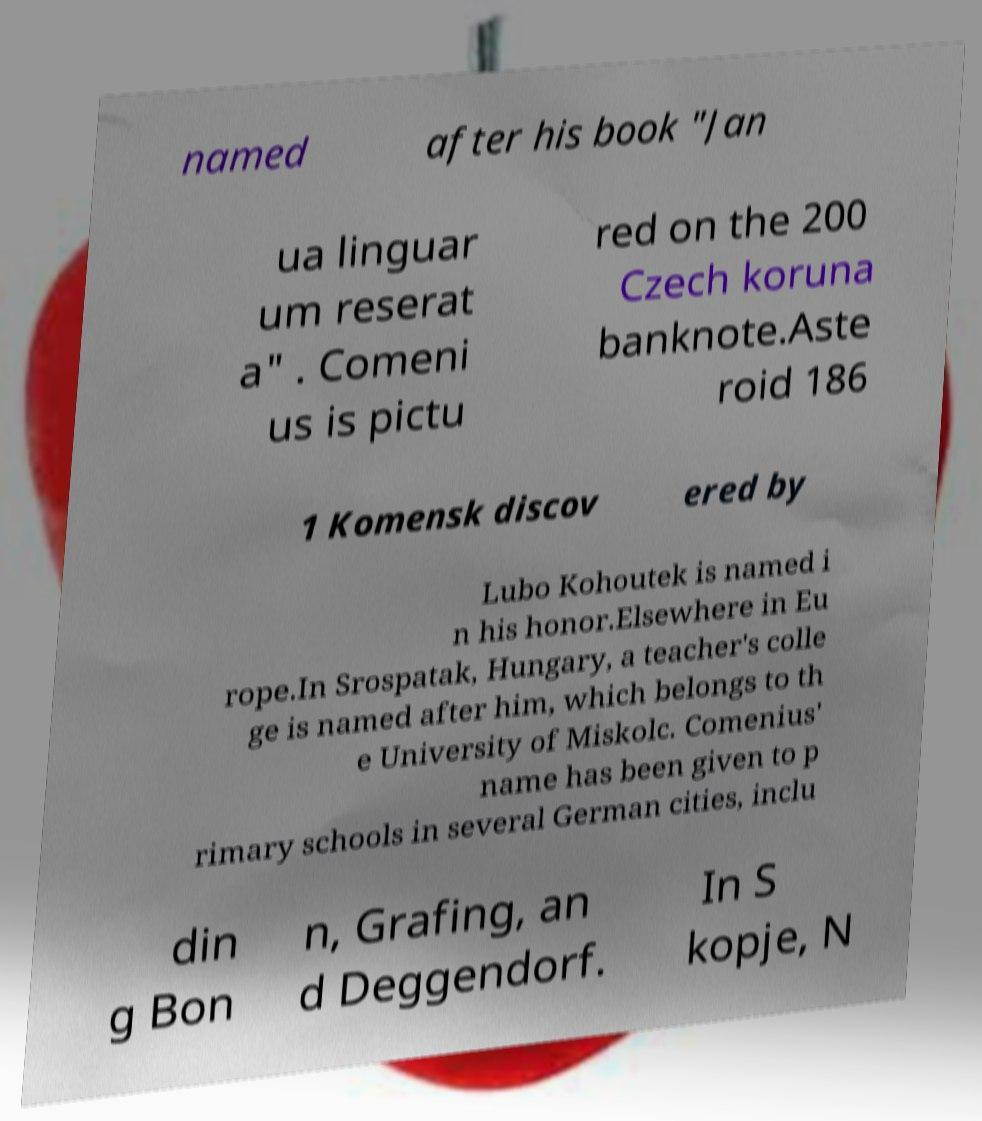There's text embedded in this image that I need extracted. Can you transcribe it verbatim? named after his book "Jan ua linguar um reserat a" . Comeni us is pictu red on the 200 Czech koruna banknote.Aste roid 186 1 Komensk discov ered by Lubo Kohoutek is named i n his honor.Elsewhere in Eu rope.In Srospatak, Hungary, a teacher's colle ge is named after him, which belongs to th e University of Miskolc. Comenius' name has been given to p rimary schools in several German cities, inclu din g Bon n, Grafing, an d Deggendorf. In S kopje, N 